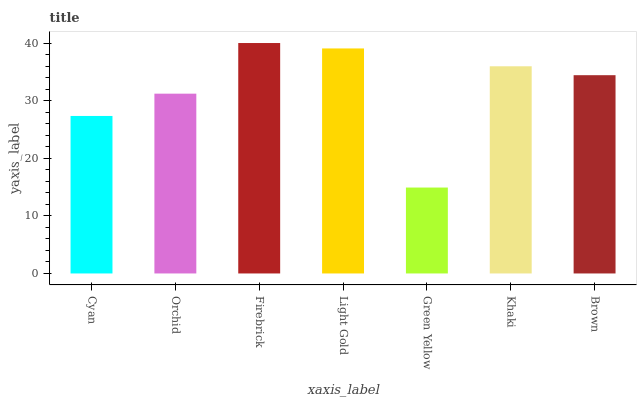Is Green Yellow the minimum?
Answer yes or no. Yes. Is Firebrick the maximum?
Answer yes or no. Yes. Is Orchid the minimum?
Answer yes or no. No. Is Orchid the maximum?
Answer yes or no. No. Is Orchid greater than Cyan?
Answer yes or no. Yes. Is Cyan less than Orchid?
Answer yes or no. Yes. Is Cyan greater than Orchid?
Answer yes or no. No. Is Orchid less than Cyan?
Answer yes or no. No. Is Brown the high median?
Answer yes or no. Yes. Is Brown the low median?
Answer yes or no. Yes. Is Orchid the high median?
Answer yes or no. No. Is Orchid the low median?
Answer yes or no. No. 